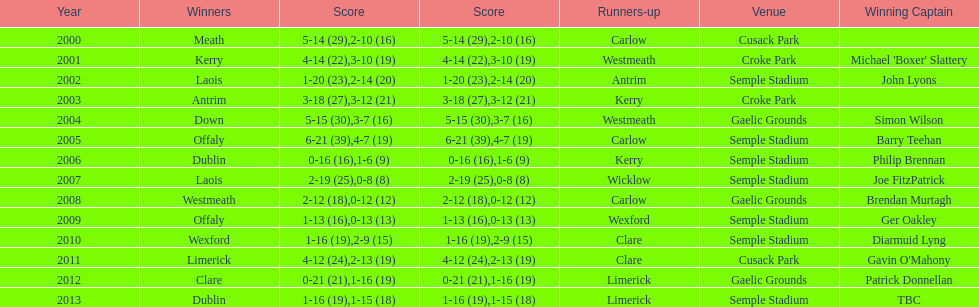Who claimed the winning title post-2007? Laois. 